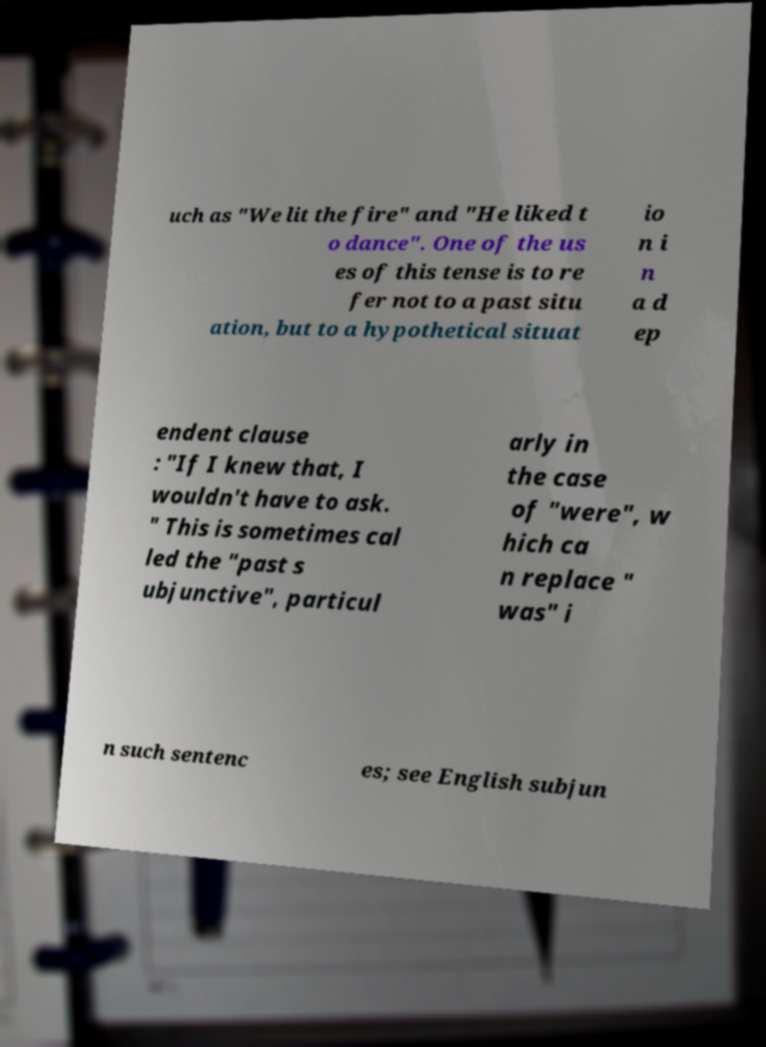I need the written content from this picture converted into text. Can you do that? uch as "We lit the fire" and "He liked t o dance". One of the us es of this tense is to re fer not to a past situ ation, but to a hypothetical situat io n i n a d ep endent clause : "If I knew that, I wouldn't have to ask. " This is sometimes cal led the "past s ubjunctive", particul arly in the case of "were", w hich ca n replace " was" i n such sentenc es; see English subjun 